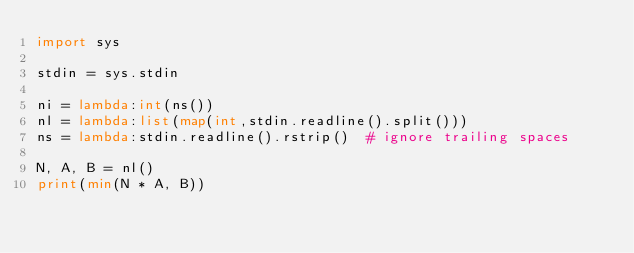Convert code to text. <code><loc_0><loc_0><loc_500><loc_500><_Python_>import sys

stdin = sys.stdin
 
ni = lambda:int(ns())
nl = lambda:list(map(int,stdin.readline().split()))
ns = lambda:stdin.readline().rstrip()  # ignore trailing spaces

N, A, B = nl()
print(min(N * A, B))</code> 